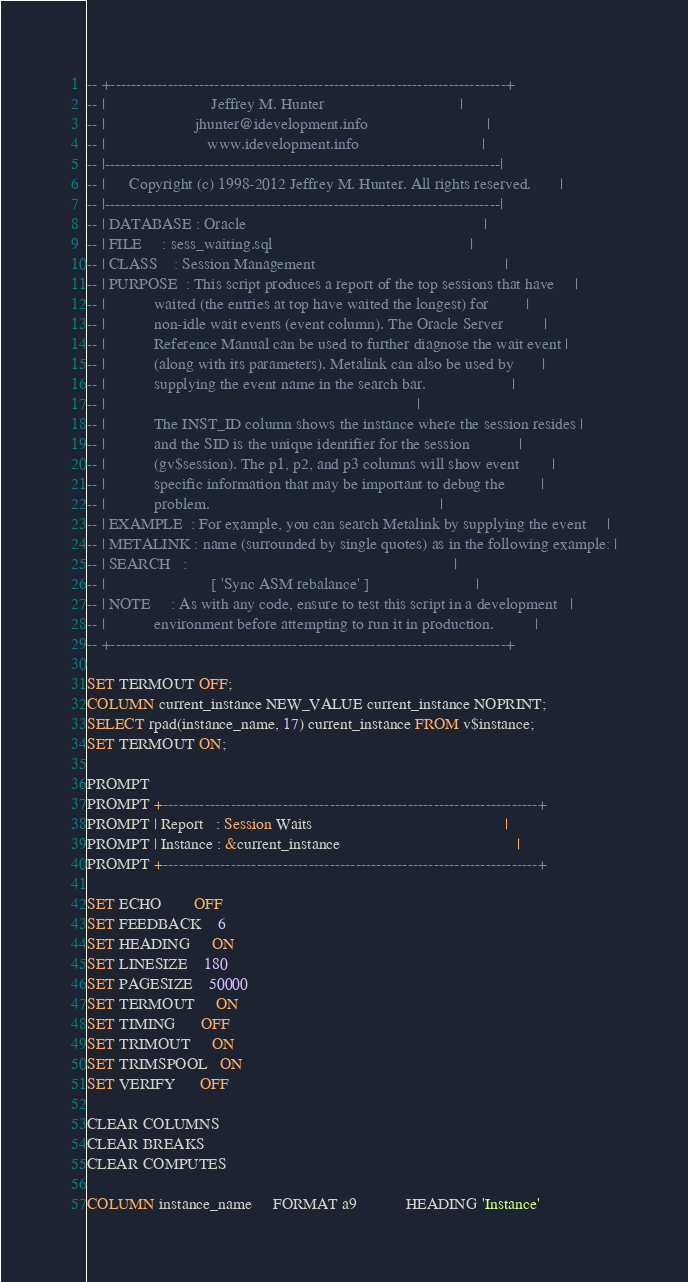Convert code to text. <code><loc_0><loc_0><loc_500><loc_500><_SQL_>-- +----------------------------------------------------------------------------+
-- |                          Jeffrey M. Hunter                                 |
-- |                      jhunter@idevelopment.info                             |
-- |                         www.idevelopment.info                              |
-- |----------------------------------------------------------------------------|
-- |      Copyright (c) 1998-2012 Jeffrey M. Hunter. All rights reserved.       |
-- |----------------------------------------------------------------------------|
-- | DATABASE : Oracle                                                          |
-- | FILE     : sess_waiting.sql                                                |
-- | CLASS    : Session Management                                              |
-- | PURPOSE  : This script produces a report of the top sessions that have     |
-- |            waited (the entries at top have waited the longest) for         |
-- |            non-idle wait events (event column). The Oracle Server          |
-- |            Reference Manual can be used to further diagnose the wait event |
-- |            (along with its parameters). Metalink can also be used by       |
-- |            supplying the event name in the search bar.                     |
-- |                                                                            |
-- |            The INST_ID column shows the instance where the session resides |
-- |            and the SID is the unique identifier for the session            |
-- |            (gv$session). The p1, p2, and p3 columns will show event        |
-- |            specific information that may be important to debug the         |
-- |            problem.                                                        |
-- | EXAMPLE  : For example, you can search Metalink by supplying the event     |
-- | METALINK : name (surrounded by single quotes) as in the following example: |
-- | SEARCH   :                                                                 |
-- |                          [ 'Sync ASM rebalance' ]                          |
-- | NOTE     : As with any code, ensure to test this script in a development   |
-- |            environment before attempting to run it in production.          |
-- +----------------------------------------------------------------------------+

SET TERMOUT OFF;
COLUMN current_instance NEW_VALUE current_instance NOPRINT;
SELECT rpad(instance_name, 17) current_instance FROM v$instance;
SET TERMOUT ON;

PROMPT 
PROMPT +------------------------------------------------------------------------+
PROMPT | Report   : Session Waits                                               |
PROMPT | Instance : &current_instance                                           |
PROMPT +------------------------------------------------------------------------+

SET ECHO        OFF
SET FEEDBACK    6
SET HEADING     ON
SET LINESIZE    180
SET PAGESIZE    50000
SET TERMOUT     ON
SET TIMING      OFF
SET TRIMOUT     ON
SET TRIMSPOOL   ON
SET VERIFY      OFF

CLEAR COLUMNS
CLEAR BREAKS
CLEAR COMPUTES

COLUMN instance_name     FORMAT a9            HEADING 'Instance'</code> 